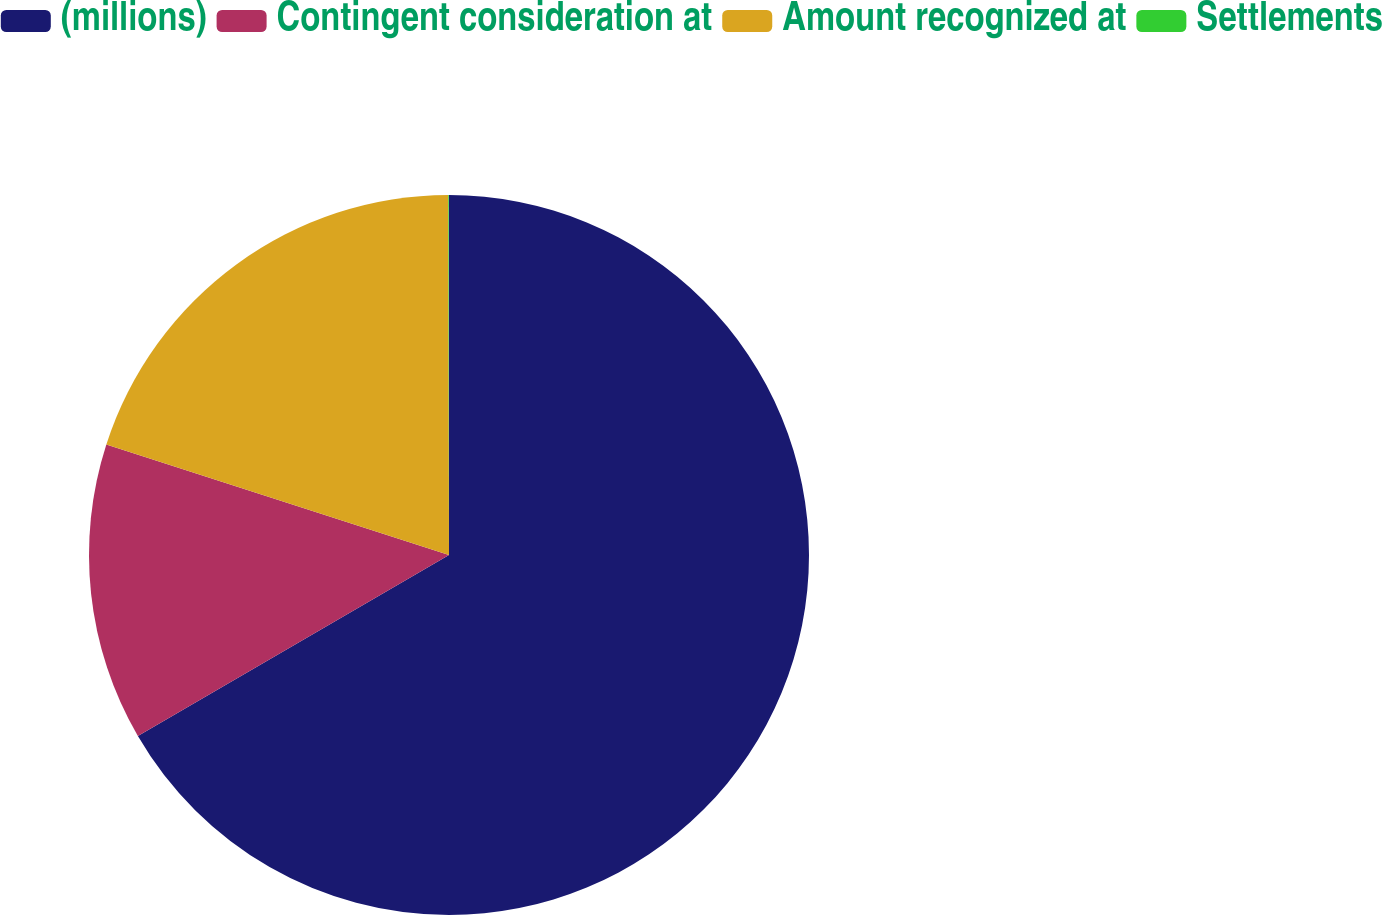Convert chart to OTSL. <chart><loc_0><loc_0><loc_500><loc_500><pie_chart><fcel>(millions)<fcel>Contingent consideration at<fcel>Amount recognized at<fcel>Settlements<nl><fcel>66.61%<fcel>13.35%<fcel>20.01%<fcel>0.03%<nl></chart> 